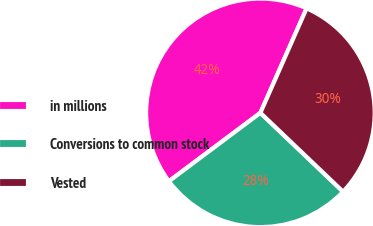Convert chart to OTSL. <chart><loc_0><loc_0><loc_500><loc_500><pie_chart><fcel>in millions<fcel>Conversions to common stock<fcel>Vested<nl><fcel>41.85%<fcel>27.66%<fcel>30.5%<nl></chart> 